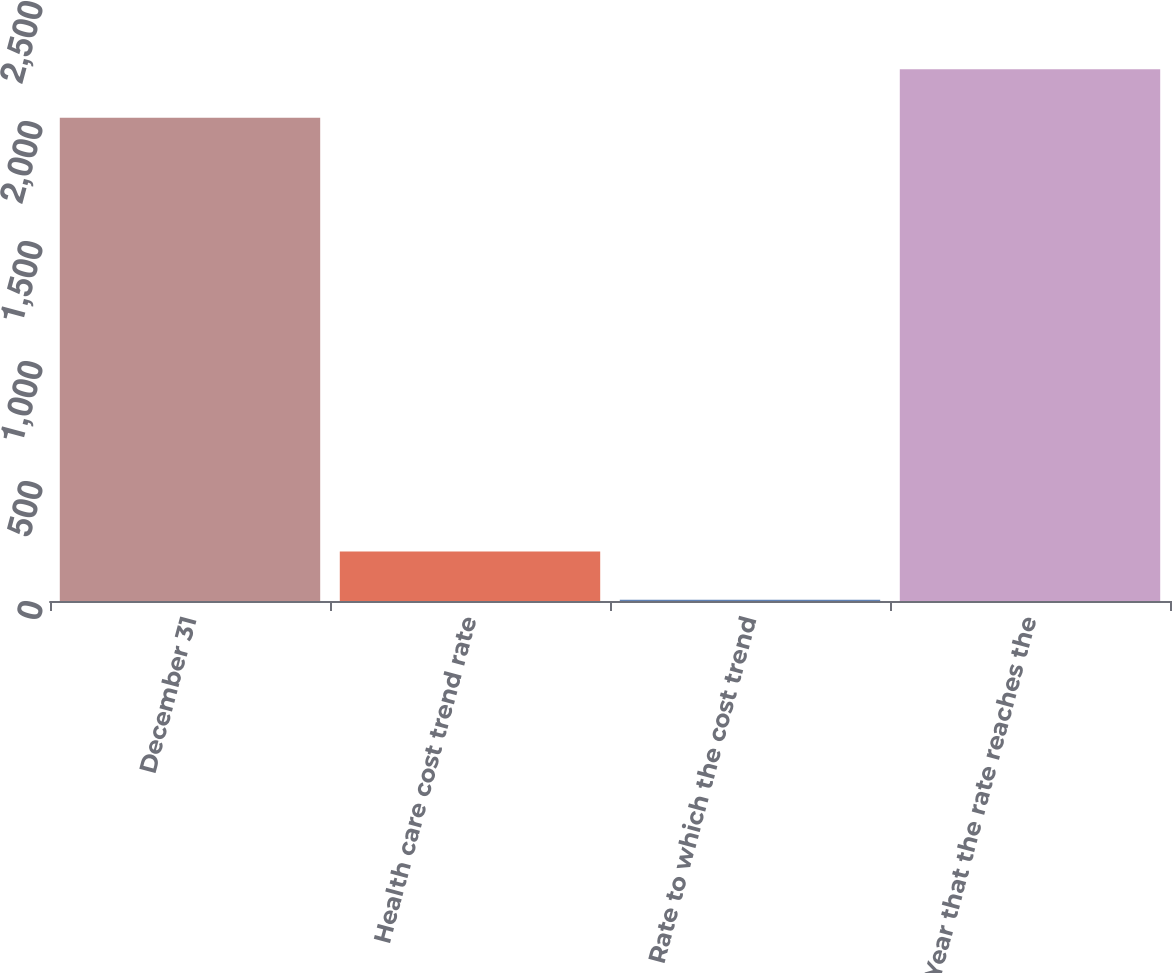<chart> <loc_0><loc_0><loc_500><loc_500><bar_chart><fcel>December 31<fcel>Health care cost trend rate<fcel>Rate to which the cost trend<fcel>Year that the rate reaches the<nl><fcel>2014<fcel>206.5<fcel>5<fcel>2215.5<nl></chart> 